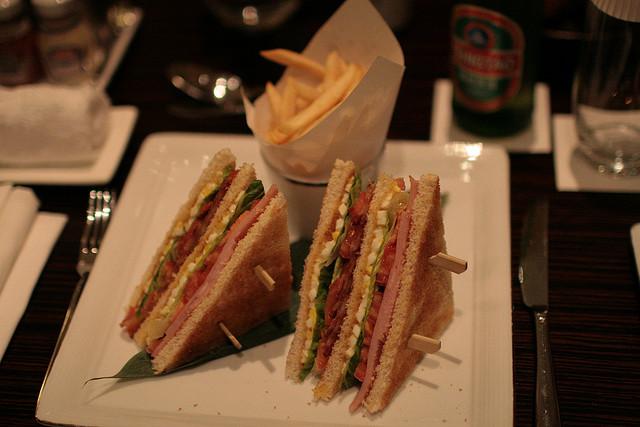What type of sandwich is being served?
Write a very short answer. Club. What shape is the plate?
Write a very short answer. Square. What is in the cone?
Answer briefly. French fries. Is everything on the plate edible?
Write a very short answer. No. 